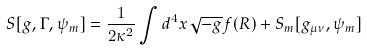<formula> <loc_0><loc_0><loc_500><loc_500>S [ { g } , \Gamma , \psi _ { m } ] = \frac { 1 } { 2 \kappa ^ { 2 } } \int d ^ { 4 } x \sqrt { - { g } } f ( { R } ) + S _ { m } [ { g } _ { \mu \nu } , \psi _ { m } ]</formula> 